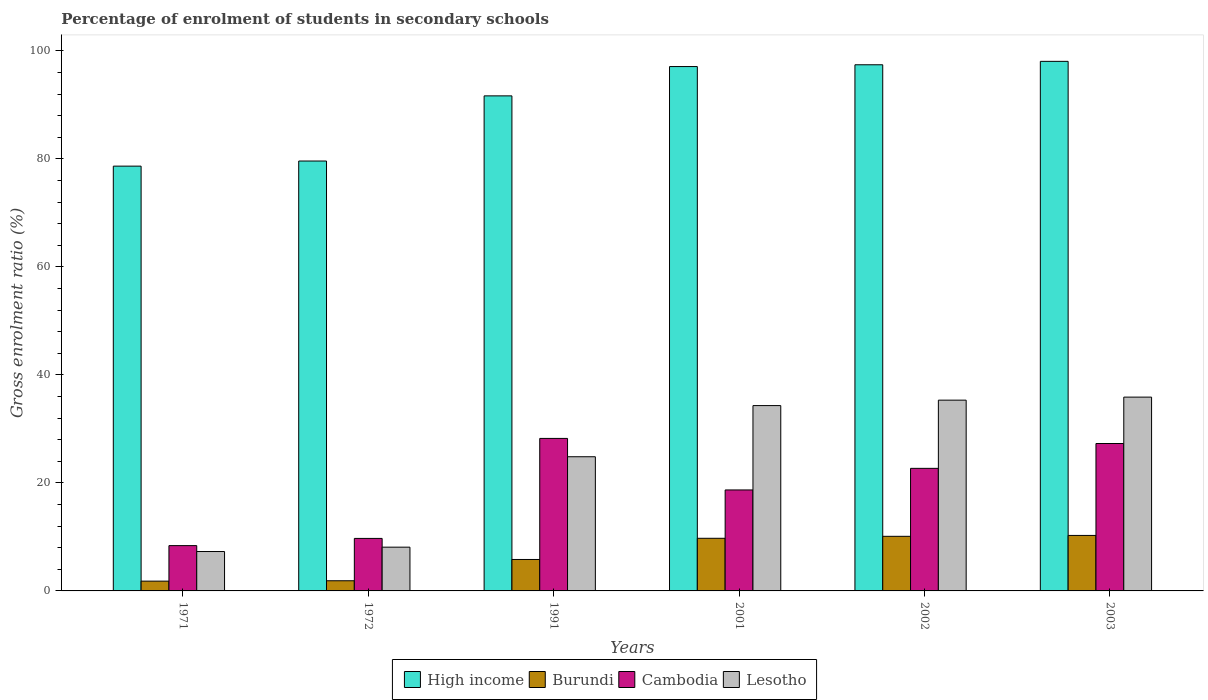Are the number of bars per tick equal to the number of legend labels?
Keep it short and to the point. Yes. How many bars are there on the 6th tick from the left?
Your answer should be very brief. 4. What is the label of the 6th group of bars from the left?
Keep it short and to the point. 2003. What is the percentage of students enrolled in secondary schools in High income in 2003?
Provide a short and direct response. 98.05. Across all years, what is the maximum percentage of students enrolled in secondary schools in High income?
Give a very brief answer. 98.05. Across all years, what is the minimum percentage of students enrolled in secondary schools in Cambodia?
Keep it short and to the point. 8.39. In which year was the percentage of students enrolled in secondary schools in Cambodia minimum?
Provide a succinct answer. 1971. What is the total percentage of students enrolled in secondary schools in Burundi in the graph?
Ensure brevity in your answer.  39.65. What is the difference between the percentage of students enrolled in secondary schools in Cambodia in 1991 and that in 2002?
Your answer should be compact. 5.55. What is the difference between the percentage of students enrolled in secondary schools in Lesotho in 2001 and the percentage of students enrolled in secondary schools in Cambodia in 1971?
Your answer should be compact. 25.93. What is the average percentage of students enrolled in secondary schools in Cambodia per year?
Your answer should be compact. 19.17. In the year 1991, what is the difference between the percentage of students enrolled in secondary schools in Cambodia and percentage of students enrolled in secondary schools in Burundi?
Your answer should be very brief. 22.42. What is the ratio of the percentage of students enrolled in secondary schools in Cambodia in 2002 to that in 2003?
Provide a short and direct response. 0.83. Is the difference between the percentage of students enrolled in secondary schools in Cambodia in 1991 and 2001 greater than the difference between the percentage of students enrolled in secondary schools in Burundi in 1991 and 2001?
Give a very brief answer. Yes. What is the difference between the highest and the second highest percentage of students enrolled in secondary schools in Cambodia?
Give a very brief answer. 0.94. What is the difference between the highest and the lowest percentage of students enrolled in secondary schools in Burundi?
Ensure brevity in your answer.  8.46. In how many years, is the percentage of students enrolled in secondary schools in Burundi greater than the average percentage of students enrolled in secondary schools in Burundi taken over all years?
Provide a short and direct response. 3. Is the sum of the percentage of students enrolled in secondary schools in Cambodia in 1971 and 1991 greater than the maximum percentage of students enrolled in secondary schools in High income across all years?
Offer a very short reply. No. What does the 4th bar from the left in 1971 represents?
Ensure brevity in your answer.  Lesotho. What does the 1st bar from the right in 1971 represents?
Your response must be concise. Lesotho. How many bars are there?
Your answer should be compact. 24. What is the difference between two consecutive major ticks on the Y-axis?
Provide a short and direct response. 20. Are the values on the major ticks of Y-axis written in scientific E-notation?
Your answer should be very brief. No. Where does the legend appear in the graph?
Offer a very short reply. Bottom center. How are the legend labels stacked?
Provide a succinct answer. Horizontal. What is the title of the graph?
Make the answer very short. Percentage of enrolment of students in secondary schools. Does "Japan" appear as one of the legend labels in the graph?
Ensure brevity in your answer.  No. What is the label or title of the Y-axis?
Offer a very short reply. Gross enrolment ratio (%). What is the Gross enrolment ratio (%) of High income in 1971?
Offer a very short reply. 78.65. What is the Gross enrolment ratio (%) of Burundi in 1971?
Offer a terse response. 1.81. What is the Gross enrolment ratio (%) of Cambodia in 1971?
Provide a succinct answer. 8.39. What is the Gross enrolment ratio (%) of Lesotho in 1971?
Provide a succinct answer. 7.29. What is the Gross enrolment ratio (%) in High income in 1972?
Your response must be concise. 79.6. What is the Gross enrolment ratio (%) in Burundi in 1972?
Make the answer very short. 1.88. What is the Gross enrolment ratio (%) in Cambodia in 1972?
Give a very brief answer. 9.72. What is the Gross enrolment ratio (%) of Lesotho in 1972?
Provide a succinct answer. 8.1. What is the Gross enrolment ratio (%) in High income in 1991?
Your answer should be very brief. 91.66. What is the Gross enrolment ratio (%) in Burundi in 1991?
Keep it short and to the point. 5.82. What is the Gross enrolment ratio (%) in Cambodia in 1991?
Offer a very short reply. 28.24. What is the Gross enrolment ratio (%) of Lesotho in 1991?
Your response must be concise. 24.84. What is the Gross enrolment ratio (%) in High income in 2001?
Your answer should be very brief. 97.09. What is the Gross enrolment ratio (%) in Burundi in 2001?
Your response must be concise. 9.75. What is the Gross enrolment ratio (%) of Cambodia in 2001?
Provide a short and direct response. 18.7. What is the Gross enrolment ratio (%) in Lesotho in 2001?
Your answer should be very brief. 34.32. What is the Gross enrolment ratio (%) in High income in 2002?
Make the answer very short. 97.42. What is the Gross enrolment ratio (%) in Burundi in 2002?
Your answer should be compact. 10.11. What is the Gross enrolment ratio (%) in Cambodia in 2002?
Offer a very short reply. 22.69. What is the Gross enrolment ratio (%) in Lesotho in 2002?
Offer a very short reply. 35.32. What is the Gross enrolment ratio (%) in High income in 2003?
Provide a succinct answer. 98.05. What is the Gross enrolment ratio (%) in Burundi in 2003?
Offer a very short reply. 10.27. What is the Gross enrolment ratio (%) in Cambodia in 2003?
Your response must be concise. 27.29. What is the Gross enrolment ratio (%) in Lesotho in 2003?
Provide a short and direct response. 35.88. Across all years, what is the maximum Gross enrolment ratio (%) in High income?
Keep it short and to the point. 98.05. Across all years, what is the maximum Gross enrolment ratio (%) of Burundi?
Your answer should be very brief. 10.27. Across all years, what is the maximum Gross enrolment ratio (%) in Cambodia?
Offer a terse response. 28.24. Across all years, what is the maximum Gross enrolment ratio (%) in Lesotho?
Ensure brevity in your answer.  35.88. Across all years, what is the minimum Gross enrolment ratio (%) of High income?
Ensure brevity in your answer.  78.65. Across all years, what is the minimum Gross enrolment ratio (%) in Burundi?
Provide a succinct answer. 1.81. Across all years, what is the minimum Gross enrolment ratio (%) of Cambodia?
Keep it short and to the point. 8.39. Across all years, what is the minimum Gross enrolment ratio (%) of Lesotho?
Your answer should be very brief. 7.29. What is the total Gross enrolment ratio (%) of High income in the graph?
Ensure brevity in your answer.  542.47. What is the total Gross enrolment ratio (%) of Burundi in the graph?
Provide a succinct answer. 39.65. What is the total Gross enrolment ratio (%) in Cambodia in the graph?
Give a very brief answer. 115.03. What is the total Gross enrolment ratio (%) in Lesotho in the graph?
Your response must be concise. 145.76. What is the difference between the Gross enrolment ratio (%) of High income in 1971 and that in 1972?
Your response must be concise. -0.95. What is the difference between the Gross enrolment ratio (%) of Burundi in 1971 and that in 1972?
Provide a succinct answer. -0.07. What is the difference between the Gross enrolment ratio (%) in Cambodia in 1971 and that in 1972?
Give a very brief answer. -1.33. What is the difference between the Gross enrolment ratio (%) in Lesotho in 1971 and that in 1972?
Ensure brevity in your answer.  -0.81. What is the difference between the Gross enrolment ratio (%) of High income in 1971 and that in 1991?
Provide a succinct answer. -13.01. What is the difference between the Gross enrolment ratio (%) in Burundi in 1971 and that in 1991?
Offer a terse response. -4.01. What is the difference between the Gross enrolment ratio (%) in Cambodia in 1971 and that in 1991?
Provide a succinct answer. -19.85. What is the difference between the Gross enrolment ratio (%) in Lesotho in 1971 and that in 1991?
Provide a succinct answer. -17.55. What is the difference between the Gross enrolment ratio (%) of High income in 1971 and that in 2001?
Ensure brevity in your answer.  -18.44. What is the difference between the Gross enrolment ratio (%) of Burundi in 1971 and that in 2001?
Your answer should be very brief. -7.93. What is the difference between the Gross enrolment ratio (%) in Cambodia in 1971 and that in 2001?
Your answer should be compact. -10.31. What is the difference between the Gross enrolment ratio (%) of Lesotho in 1971 and that in 2001?
Provide a succinct answer. -27.02. What is the difference between the Gross enrolment ratio (%) of High income in 1971 and that in 2002?
Offer a very short reply. -18.77. What is the difference between the Gross enrolment ratio (%) of Burundi in 1971 and that in 2002?
Your answer should be very brief. -8.3. What is the difference between the Gross enrolment ratio (%) in Cambodia in 1971 and that in 2002?
Your answer should be very brief. -14.31. What is the difference between the Gross enrolment ratio (%) in Lesotho in 1971 and that in 2002?
Give a very brief answer. -28.03. What is the difference between the Gross enrolment ratio (%) in High income in 1971 and that in 2003?
Keep it short and to the point. -19.4. What is the difference between the Gross enrolment ratio (%) of Burundi in 1971 and that in 2003?
Ensure brevity in your answer.  -8.46. What is the difference between the Gross enrolment ratio (%) of Cambodia in 1971 and that in 2003?
Offer a terse response. -18.91. What is the difference between the Gross enrolment ratio (%) in Lesotho in 1971 and that in 2003?
Offer a very short reply. -28.59. What is the difference between the Gross enrolment ratio (%) in High income in 1972 and that in 1991?
Offer a very short reply. -12.06. What is the difference between the Gross enrolment ratio (%) in Burundi in 1972 and that in 1991?
Provide a short and direct response. -3.94. What is the difference between the Gross enrolment ratio (%) of Cambodia in 1972 and that in 1991?
Provide a succinct answer. -18.52. What is the difference between the Gross enrolment ratio (%) of Lesotho in 1972 and that in 1991?
Your response must be concise. -16.74. What is the difference between the Gross enrolment ratio (%) in High income in 1972 and that in 2001?
Make the answer very short. -17.49. What is the difference between the Gross enrolment ratio (%) in Burundi in 1972 and that in 2001?
Offer a very short reply. -7.86. What is the difference between the Gross enrolment ratio (%) of Cambodia in 1972 and that in 2001?
Provide a short and direct response. -8.98. What is the difference between the Gross enrolment ratio (%) of Lesotho in 1972 and that in 2001?
Offer a terse response. -26.21. What is the difference between the Gross enrolment ratio (%) of High income in 1972 and that in 2002?
Make the answer very short. -17.82. What is the difference between the Gross enrolment ratio (%) of Burundi in 1972 and that in 2002?
Make the answer very short. -8.23. What is the difference between the Gross enrolment ratio (%) of Cambodia in 1972 and that in 2002?
Your answer should be compact. -12.97. What is the difference between the Gross enrolment ratio (%) in Lesotho in 1972 and that in 2002?
Keep it short and to the point. -27.22. What is the difference between the Gross enrolment ratio (%) in High income in 1972 and that in 2003?
Make the answer very short. -18.45. What is the difference between the Gross enrolment ratio (%) in Burundi in 1972 and that in 2003?
Your answer should be compact. -8.39. What is the difference between the Gross enrolment ratio (%) in Cambodia in 1972 and that in 2003?
Your answer should be compact. -17.57. What is the difference between the Gross enrolment ratio (%) of Lesotho in 1972 and that in 2003?
Your response must be concise. -27.78. What is the difference between the Gross enrolment ratio (%) in High income in 1991 and that in 2001?
Give a very brief answer. -5.43. What is the difference between the Gross enrolment ratio (%) in Burundi in 1991 and that in 2001?
Your answer should be very brief. -3.92. What is the difference between the Gross enrolment ratio (%) of Cambodia in 1991 and that in 2001?
Keep it short and to the point. 9.54. What is the difference between the Gross enrolment ratio (%) in Lesotho in 1991 and that in 2001?
Provide a succinct answer. -9.47. What is the difference between the Gross enrolment ratio (%) in High income in 1991 and that in 2002?
Provide a short and direct response. -5.76. What is the difference between the Gross enrolment ratio (%) in Burundi in 1991 and that in 2002?
Provide a succinct answer. -4.29. What is the difference between the Gross enrolment ratio (%) of Cambodia in 1991 and that in 2002?
Offer a terse response. 5.55. What is the difference between the Gross enrolment ratio (%) of Lesotho in 1991 and that in 2002?
Provide a succinct answer. -10.48. What is the difference between the Gross enrolment ratio (%) of High income in 1991 and that in 2003?
Your answer should be compact. -6.39. What is the difference between the Gross enrolment ratio (%) in Burundi in 1991 and that in 2003?
Keep it short and to the point. -4.45. What is the difference between the Gross enrolment ratio (%) of Cambodia in 1991 and that in 2003?
Offer a very short reply. 0.94. What is the difference between the Gross enrolment ratio (%) in Lesotho in 1991 and that in 2003?
Provide a succinct answer. -11.04. What is the difference between the Gross enrolment ratio (%) in High income in 2001 and that in 2002?
Keep it short and to the point. -0.33. What is the difference between the Gross enrolment ratio (%) of Burundi in 2001 and that in 2002?
Provide a succinct answer. -0.36. What is the difference between the Gross enrolment ratio (%) in Cambodia in 2001 and that in 2002?
Your answer should be compact. -4. What is the difference between the Gross enrolment ratio (%) in Lesotho in 2001 and that in 2002?
Make the answer very short. -1.01. What is the difference between the Gross enrolment ratio (%) of High income in 2001 and that in 2003?
Your answer should be very brief. -0.96. What is the difference between the Gross enrolment ratio (%) in Burundi in 2001 and that in 2003?
Provide a short and direct response. -0.53. What is the difference between the Gross enrolment ratio (%) of Cambodia in 2001 and that in 2003?
Your answer should be very brief. -8.6. What is the difference between the Gross enrolment ratio (%) of Lesotho in 2001 and that in 2003?
Offer a terse response. -1.57. What is the difference between the Gross enrolment ratio (%) in High income in 2002 and that in 2003?
Keep it short and to the point. -0.63. What is the difference between the Gross enrolment ratio (%) of Burundi in 2002 and that in 2003?
Ensure brevity in your answer.  -0.16. What is the difference between the Gross enrolment ratio (%) in Cambodia in 2002 and that in 2003?
Keep it short and to the point. -4.6. What is the difference between the Gross enrolment ratio (%) in Lesotho in 2002 and that in 2003?
Provide a succinct answer. -0.56. What is the difference between the Gross enrolment ratio (%) in High income in 1971 and the Gross enrolment ratio (%) in Burundi in 1972?
Your answer should be compact. 76.77. What is the difference between the Gross enrolment ratio (%) of High income in 1971 and the Gross enrolment ratio (%) of Cambodia in 1972?
Provide a succinct answer. 68.93. What is the difference between the Gross enrolment ratio (%) of High income in 1971 and the Gross enrolment ratio (%) of Lesotho in 1972?
Your response must be concise. 70.55. What is the difference between the Gross enrolment ratio (%) in Burundi in 1971 and the Gross enrolment ratio (%) in Cambodia in 1972?
Your response must be concise. -7.91. What is the difference between the Gross enrolment ratio (%) in Burundi in 1971 and the Gross enrolment ratio (%) in Lesotho in 1972?
Keep it short and to the point. -6.29. What is the difference between the Gross enrolment ratio (%) in Cambodia in 1971 and the Gross enrolment ratio (%) in Lesotho in 1972?
Ensure brevity in your answer.  0.29. What is the difference between the Gross enrolment ratio (%) of High income in 1971 and the Gross enrolment ratio (%) of Burundi in 1991?
Ensure brevity in your answer.  72.83. What is the difference between the Gross enrolment ratio (%) in High income in 1971 and the Gross enrolment ratio (%) in Cambodia in 1991?
Make the answer very short. 50.41. What is the difference between the Gross enrolment ratio (%) of High income in 1971 and the Gross enrolment ratio (%) of Lesotho in 1991?
Make the answer very short. 53.81. What is the difference between the Gross enrolment ratio (%) of Burundi in 1971 and the Gross enrolment ratio (%) of Cambodia in 1991?
Ensure brevity in your answer.  -26.43. What is the difference between the Gross enrolment ratio (%) in Burundi in 1971 and the Gross enrolment ratio (%) in Lesotho in 1991?
Ensure brevity in your answer.  -23.03. What is the difference between the Gross enrolment ratio (%) of Cambodia in 1971 and the Gross enrolment ratio (%) of Lesotho in 1991?
Your answer should be very brief. -16.46. What is the difference between the Gross enrolment ratio (%) of High income in 1971 and the Gross enrolment ratio (%) of Burundi in 2001?
Your answer should be very brief. 68.91. What is the difference between the Gross enrolment ratio (%) in High income in 1971 and the Gross enrolment ratio (%) in Cambodia in 2001?
Your answer should be compact. 59.95. What is the difference between the Gross enrolment ratio (%) of High income in 1971 and the Gross enrolment ratio (%) of Lesotho in 2001?
Make the answer very short. 44.34. What is the difference between the Gross enrolment ratio (%) of Burundi in 1971 and the Gross enrolment ratio (%) of Cambodia in 2001?
Your response must be concise. -16.89. What is the difference between the Gross enrolment ratio (%) of Burundi in 1971 and the Gross enrolment ratio (%) of Lesotho in 2001?
Your response must be concise. -32.5. What is the difference between the Gross enrolment ratio (%) in Cambodia in 1971 and the Gross enrolment ratio (%) in Lesotho in 2001?
Your response must be concise. -25.93. What is the difference between the Gross enrolment ratio (%) of High income in 1971 and the Gross enrolment ratio (%) of Burundi in 2002?
Your answer should be compact. 68.54. What is the difference between the Gross enrolment ratio (%) of High income in 1971 and the Gross enrolment ratio (%) of Cambodia in 2002?
Your response must be concise. 55.96. What is the difference between the Gross enrolment ratio (%) of High income in 1971 and the Gross enrolment ratio (%) of Lesotho in 2002?
Provide a short and direct response. 43.33. What is the difference between the Gross enrolment ratio (%) of Burundi in 1971 and the Gross enrolment ratio (%) of Cambodia in 2002?
Your response must be concise. -20.88. What is the difference between the Gross enrolment ratio (%) of Burundi in 1971 and the Gross enrolment ratio (%) of Lesotho in 2002?
Offer a very short reply. -33.51. What is the difference between the Gross enrolment ratio (%) in Cambodia in 1971 and the Gross enrolment ratio (%) in Lesotho in 2002?
Offer a very short reply. -26.93. What is the difference between the Gross enrolment ratio (%) of High income in 1971 and the Gross enrolment ratio (%) of Burundi in 2003?
Give a very brief answer. 68.38. What is the difference between the Gross enrolment ratio (%) in High income in 1971 and the Gross enrolment ratio (%) in Cambodia in 2003?
Provide a succinct answer. 51.36. What is the difference between the Gross enrolment ratio (%) of High income in 1971 and the Gross enrolment ratio (%) of Lesotho in 2003?
Your answer should be very brief. 42.77. What is the difference between the Gross enrolment ratio (%) of Burundi in 1971 and the Gross enrolment ratio (%) of Cambodia in 2003?
Make the answer very short. -25.48. What is the difference between the Gross enrolment ratio (%) of Burundi in 1971 and the Gross enrolment ratio (%) of Lesotho in 2003?
Your answer should be compact. -34.07. What is the difference between the Gross enrolment ratio (%) in Cambodia in 1971 and the Gross enrolment ratio (%) in Lesotho in 2003?
Make the answer very short. -27.5. What is the difference between the Gross enrolment ratio (%) of High income in 1972 and the Gross enrolment ratio (%) of Burundi in 1991?
Your response must be concise. 73.78. What is the difference between the Gross enrolment ratio (%) in High income in 1972 and the Gross enrolment ratio (%) in Cambodia in 1991?
Give a very brief answer. 51.36. What is the difference between the Gross enrolment ratio (%) of High income in 1972 and the Gross enrolment ratio (%) of Lesotho in 1991?
Make the answer very short. 54.76. What is the difference between the Gross enrolment ratio (%) in Burundi in 1972 and the Gross enrolment ratio (%) in Cambodia in 1991?
Provide a succinct answer. -26.36. What is the difference between the Gross enrolment ratio (%) of Burundi in 1972 and the Gross enrolment ratio (%) of Lesotho in 1991?
Your answer should be compact. -22.96. What is the difference between the Gross enrolment ratio (%) of Cambodia in 1972 and the Gross enrolment ratio (%) of Lesotho in 1991?
Your answer should be very brief. -15.12. What is the difference between the Gross enrolment ratio (%) of High income in 1972 and the Gross enrolment ratio (%) of Burundi in 2001?
Your response must be concise. 69.85. What is the difference between the Gross enrolment ratio (%) in High income in 1972 and the Gross enrolment ratio (%) in Cambodia in 2001?
Keep it short and to the point. 60.9. What is the difference between the Gross enrolment ratio (%) of High income in 1972 and the Gross enrolment ratio (%) of Lesotho in 2001?
Offer a terse response. 45.28. What is the difference between the Gross enrolment ratio (%) in Burundi in 1972 and the Gross enrolment ratio (%) in Cambodia in 2001?
Provide a succinct answer. -16.82. What is the difference between the Gross enrolment ratio (%) in Burundi in 1972 and the Gross enrolment ratio (%) in Lesotho in 2001?
Make the answer very short. -32.43. What is the difference between the Gross enrolment ratio (%) of Cambodia in 1972 and the Gross enrolment ratio (%) of Lesotho in 2001?
Offer a very short reply. -24.59. What is the difference between the Gross enrolment ratio (%) of High income in 1972 and the Gross enrolment ratio (%) of Burundi in 2002?
Offer a terse response. 69.49. What is the difference between the Gross enrolment ratio (%) of High income in 1972 and the Gross enrolment ratio (%) of Cambodia in 2002?
Your response must be concise. 56.9. What is the difference between the Gross enrolment ratio (%) in High income in 1972 and the Gross enrolment ratio (%) in Lesotho in 2002?
Keep it short and to the point. 44.28. What is the difference between the Gross enrolment ratio (%) in Burundi in 1972 and the Gross enrolment ratio (%) in Cambodia in 2002?
Your answer should be compact. -20.81. What is the difference between the Gross enrolment ratio (%) in Burundi in 1972 and the Gross enrolment ratio (%) in Lesotho in 2002?
Offer a terse response. -33.44. What is the difference between the Gross enrolment ratio (%) in Cambodia in 1972 and the Gross enrolment ratio (%) in Lesotho in 2002?
Offer a terse response. -25.6. What is the difference between the Gross enrolment ratio (%) of High income in 1972 and the Gross enrolment ratio (%) of Burundi in 2003?
Keep it short and to the point. 69.32. What is the difference between the Gross enrolment ratio (%) of High income in 1972 and the Gross enrolment ratio (%) of Cambodia in 2003?
Offer a terse response. 52.3. What is the difference between the Gross enrolment ratio (%) in High income in 1972 and the Gross enrolment ratio (%) in Lesotho in 2003?
Offer a terse response. 43.71. What is the difference between the Gross enrolment ratio (%) of Burundi in 1972 and the Gross enrolment ratio (%) of Cambodia in 2003?
Your response must be concise. -25.41. What is the difference between the Gross enrolment ratio (%) of Burundi in 1972 and the Gross enrolment ratio (%) of Lesotho in 2003?
Keep it short and to the point. -34. What is the difference between the Gross enrolment ratio (%) of Cambodia in 1972 and the Gross enrolment ratio (%) of Lesotho in 2003?
Offer a terse response. -26.16. What is the difference between the Gross enrolment ratio (%) in High income in 1991 and the Gross enrolment ratio (%) in Burundi in 2001?
Ensure brevity in your answer.  81.92. What is the difference between the Gross enrolment ratio (%) in High income in 1991 and the Gross enrolment ratio (%) in Cambodia in 2001?
Offer a very short reply. 72.97. What is the difference between the Gross enrolment ratio (%) in High income in 1991 and the Gross enrolment ratio (%) in Lesotho in 2001?
Your answer should be compact. 57.35. What is the difference between the Gross enrolment ratio (%) of Burundi in 1991 and the Gross enrolment ratio (%) of Cambodia in 2001?
Keep it short and to the point. -12.88. What is the difference between the Gross enrolment ratio (%) of Burundi in 1991 and the Gross enrolment ratio (%) of Lesotho in 2001?
Your response must be concise. -28.49. What is the difference between the Gross enrolment ratio (%) in Cambodia in 1991 and the Gross enrolment ratio (%) in Lesotho in 2001?
Make the answer very short. -6.08. What is the difference between the Gross enrolment ratio (%) in High income in 1991 and the Gross enrolment ratio (%) in Burundi in 2002?
Ensure brevity in your answer.  81.55. What is the difference between the Gross enrolment ratio (%) of High income in 1991 and the Gross enrolment ratio (%) of Cambodia in 2002?
Your response must be concise. 68.97. What is the difference between the Gross enrolment ratio (%) in High income in 1991 and the Gross enrolment ratio (%) in Lesotho in 2002?
Your answer should be compact. 56.34. What is the difference between the Gross enrolment ratio (%) in Burundi in 1991 and the Gross enrolment ratio (%) in Cambodia in 2002?
Offer a very short reply. -16.87. What is the difference between the Gross enrolment ratio (%) of Burundi in 1991 and the Gross enrolment ratio (%) of Lesotho in 2002?
Keep it short and to the point. -29.5. What is the difference between the Gross enrolment ratio (%) of Cambodia in 1991 and the Gross enrolment ratio (%) of Lesotho in 2002?
Provide a succinct answer. -7.08. What is the difference between the Gross enrolment ratio (%) of High income in 1991 and the Gross enrolment ratio (%) of Burundi in 2003?
Ensure brevity in your answer.  81.39. What is the difference between the Gross enrolment ratio (%) in High income in 1991 and the Gross enrolment ratio (%) in Cambodia in 2003?
Your answer should be very brief. 64.37. What is the difference between the Gross enrolment ratio (%) in High income in 1991 and the Gross enrolment ratio (%) in Lesotho in 2003?
Make the answer very short. 55.78. What is the difference between the Gross enrolment ratio (%) in Burundi in 1991 and the Gross enrolment ratio (%) in Cambodia in 2003?
Your response must be concise. -21.47. What is the difference between the Gross enrolment ratio (%) of Burundi in 1991 and the Gross enrolment ratio (%) of Lesotho in 2003?
Give a very brief answer. -30.06. What is the difference between the Gross enrolment ratio (%) of Cambodia in 1991 and the Gross enrolment ratio (%) of Lesotho in 2003?
Ensure brevity in your answer.  -7.64. What is the difference between the Gross enrolment ratio (%) of High income in 2001 and the Gross enrolment ratio (%) of Burundi in 2002?
Make the answer very short. 86.98. What is the difference between the Gross enrolment ratio (%) of High income in 2001 and the Gross enrolment ratio (%) of Cambodia in 2002?
Offer a very short reply. 74.4. What is the difference between the Gross enrolment ratio (%) of High income in 2001 and the Gross enrolment ratio (%) of Lesotho in 2002?
Provide a short and direct response. 61.77. What is the difference between the Gross enrolment ratio (%) in Burundi in 2001 and the Gross enrolment ratio (%) in Cambodia in 2002?
Offer a very short reply. -12.95. What is the difference between the Gross enrolment ratio (%) of Burundi in 2001 and the Gross enrolment ratio (%) of Lesotho in 2002?
Offer a terse response. -25.58. What is the difference between the Gross enrolment ratio (%) of Cambodia in 2001 and the Gross enrolment ratio (%) of Lesotho in 2002?
Ensure brevity in your answer.  -16.62. What is the difference between the Gross enrolment ratio (%) of High income in 2001 and the Gross enrolment ratio (%) of Burundi in 2003?
Provide a short and direct response. 86.82. What is the difference between the Gross enrolment ratio (%) of High income in 2001 and the Gross enrolment ratio (%) of Cambodia in 2003?
Your answer should be compact. 69.8. What is the difference between the Gross enrolment ratio (%) in High income in 2001 and the Gross enrolment ratio (%) in Lesotho in 2003?
Offer a terse response. 61.21. What is the difference between the Gross enrolment ratio (%) of Burundi in 2001 and the Gross enrolment ratio (%) of Cambodia in 2003?
Offer a terse response. -17.55. What is the difference between the Gross enrolment ratio (%) in Burundi in 2001 and the Gross enrolment ratio (%) in Lesotho in 2003?
Your answer should be very brief. -26.14. What is the difference between the Gross enrolment ratio (%) of Cambodia in 2001 and the Gross enrolment ratio (%) of Lesotho in 2003?
Ensure brevity in your answer.  -17.19. What is the difference between the Gross enrolment ratio (%) in High income in 2002 and the Gross enrolment ratio (%) in Burundi in 2003?
Ensure brevity in your answer.  87.14. What is the difference between the Gross enrolment ratio (%) in High income in 2002 and the Gross enrolment ratio (%) in Cambodia in 2003?
Make the answer very short. 70.12. What is the difference between the Gross enrolment ratio (%) in High income in 2002 and the Gross enrolment ratio (%) in Lesotho in 2003?
Ensure brevity in your answer.  61.53. What is the difference between the Gross enrolment ratio (%) of Burundi in 2002 and the Gross enrolment ratio (%) of Cambodia in 2003?
Keep it short and to the point. -17.18. What is the difference between the Gross enrolment ratio (%) of Burundi in 2002 and the Gross enrolment ratio (%) of Lesotho in 2003?
Offer a terse response. -25.77. What is the difference between the Gross enrolment ratio (%) of Cambodia in 2002 and the Gross enrolment ratio (%) of Lesotho in 2003?
Give a very brief answer. -13.19. What is the average Gross enrolment ratio (%) in High income per year?
Ensure brevity in your answer.  90.41. What is the average Gross enrolment ratio (%) in Burundi per year?
Make the answer very short. 6.61. What is the average Gross enrolment ratio (%) in Cambodia per year?
Make the answer very short. 19.17. What is the average Gross enrolment ratio (%) in Lesotho per year?
Your answer should be compact. 24.29. In the year 1971, what is the difference between the Gross enrolment ratio (%) of High income and Gross enrolment ratio (%) of Burundi?
Ensure brevity in your answer.  76.84. In the year 1971, what is the difference between the Gross enrolment ratio (%) in High income and Gross enrolment ratio (%) in Cambodia?
Your answer should be very brief. 70.26. In the year 1971, what is the difference between the Gross enrolment ratio (%) in High income and Gross enrolment ratio (%) in Lesotho?
Make the answer very short. 71.36. In the year 1971, what is the difference between the Gross enrolment ratio (%) in Burundi and Gross enrolment ratio (%) in Cambodia?
Give a very brief answer. -6.58. In the year 1971, what is the difference between the Gross enrolment ratio (%) in Burundi and Gross enrolment ratio (%) in Lesotho?
Offer a very short reply. -5.48. In the year 1971, what is the difference between the Gross enrolment ratio (%) of Cambodia and Gross enrolment ratio (%) of Lesotho?
Make the answer very short. 1.09. In the year 1972, what is the difference between the Gross enrolment ratio (%) of High income and Gross enrolment ratio (%) of Burundi?
Offer a very short reply. 77.72. In the year 1972, what is the difference between the Gross enrolment ratio (%) of High income and Gross enrolment ratio (%) of Cambodia?
Provide a short and direct response. 69.88. In the year 1972, what is the difference between the Gross enrolment ratio (%) in High income and Gross enrolment ratio (%) in Lesotho?
Your answer should be very brief. 71.5. In the year 1972, what is the difference between the Gross enrolment ratio (%) in Burundi and Gross enrolment ratio (%) in Cambodia?
Offer a terse response. -7.84. In the year 1972, what is the difference between the Gross enrolment ratio (%) in Burundi and Gross enrolment ratio (%) in Lesotho?
Ensure brevity in your answer.  -6.22. In the year 1972, what is the difference between the Gross enrolment ratio (%) of Cambodia and Gross enrolment ratio (%) of Lesotho?
Offer a terse response. 1.62. In the year 1991, what is the difference between the Gross enrolment ratio (%) in High income and Gross enrolment ratio (%) in Burundi?
Your answer should be very brief. 85.84. In the year 1991, what is the difference between the Gross enrolment ratio (%) in High income and Gross enrolment ratio (%) in Cambodia?
Your response must be concise. 63.42. In the year 1991, what is the difference between the Gross enrolment ratio (%) in High income and Gross enrolment ratio (%) in Lesotho?
Make the answer very short. 66.82. In the year 1991, what is the difference between the Gross enrolment ratio (%) of Burundi and Gross enrolment ratio (%) of Cambodia?
Offer a terse response. -22.42. In the year 1991, what is the difference between the Gross enrolment ratio (%) in Burundi and Gross enrolment ratio (%) in Lesotho?
Your answer should be very brief. -19.02. In the year 1991, what is the difference between the Gross enrolment ratio (%) in Cambodia and Gross enrolment ratio (%) in Lesotho?
Provide a short and direct response. 3.4. In the year 2001, what is the difference between the Gross enrolment ratio (%) in High income and Gross enrolment ratio (%) in Burundi?
Provide a succinct answer. 87.34. In the year 2001, what is the difference between the Gross enrolment ratio (%) in High income and Gross enrolment ratio (%) in Cambodia?
Make the answer very short. 78.39. In the year 2001, what is the difference between the Gross enrolment ratio (%) in High income and Gross enrolment ratio (%) in Lesotho?
Provide a short and direct response. 62.77. In the year 2001, what is the difference between the Gross enrolment ratio (%) in Burundi and Gross enrolment ratio (%) in Cambodia?
Your response must be concise. -8.95. In the year 2001, what is the difference between the Gross enrolment ratio (%) of Burundi and Gross enrolment ratio (%) of Lesotho?
Provide a succinct answer. -24.57. In the year 2001, what is the difference between the Gross enrolment ratio (%) in Cambodia and Gross enrolment ratio (%) in Lesotho?
Make the answer very short. -15.62. In the year 2002, what is the difference between the Gross enrolment ratio (%) in High income and Gross enrolment ratio (%) in Burundi?
Keep it short and to the point. 87.31. In the year 2002, what is the difference between the Gross enrolment ratio (%) in High income and Gross enrolment ratio (%) in Cambodia?
Provide a succinct answer. 74.72. In the year 2002, what is the difference between the Gross enrolment ratio (%) in High income and Gross enrolment ratio (%) in Lesotho?
Provide a short and direct response. 62.1. In the year 2002, what is the difference between the Gross enrolment ratio (%) in Burundi and Gross enrolment ratio (%) in Cambodia?
Offer a very short reply. -12.58. In the year 2002, what is the difference between the Gross enrolment ratio (%) of Burundi and Gross enrolment ratio (%) of Lesotho?
Your answer should be very brief. -25.21. In the year 2002, what is the difference between the Gross enrolment ratio (%) of Cambodia and Gross enrolment ratio (%) of Lesotho?
Provide a short and direct response. -12.63. In the year 2003, what is the difference between the Gross enrolment ratio (%) in High income and Gross enrolment ratio (%) in Burundi?
Provide a short and direct response. 87.78. In the year 2003, what is the difference between the Gross enrolment ratio (%) of High income and Gross enrolment ratio (%) of Cambodia?
Offer a very short reply. 70.76. In the year 2003, what is the difference between the Gross enrolment ratio (%) of High income and Gross enrolment ratio (%) of Lesotho?
Keep it short and to the point. 62.17. In the year 2003, what is the difference between the Gross enrolment ratio (%) of Burundi and Gross enrolment ratio (%) of Cambodia?
Make the answer very short. -17.02. In the year 2003, what is the difference between the Gross enrolment ratio (%) of Burundi and Gross enrolment ratio (%) of Lesotho?
Offer a terse response. -25.61. In the year 2003, what is the difference between the Gross enrolment ratio (%) of Cambodia and Gross enrolment ratio (%) of Lesotho?
Provide a succinct answer. -8.59. What is the ratio of the Gross enrolment ratio (%) in High income in 1971 to that in 1972?
Make the answer very short. 0.99. What is the ratio of the Gross enrolment ratio (%) in Burundi in 1971 to that in 1972?
Ensure brevity in your answer.  0.96. What is the ratio of the Gross enrolment ratio (%) in Cambodia in 1971 to that in 1972?
Offer a terse response. 0.86. What is the ratio of the Gross enrolment ratio (%) of Lesotho in 1971 to that in 1972?
Your answer should be very brief. 0.9. What is the ratio of the Gross enrolment ratio (%) in High income in 1971 to that in 1991?
Keep it short and to the point. 0.86. What is the ratio of the Gross enrolment ratio (%) of Burundi in 1971 to that in 1991?
Ensure brevity in your answer.  0.31. What is the ratio of the Gross enrolment ratio (%) in Cambodia in 1971 to that in 1991?
Offer a very short reply. 0.3. What is the ratio of the Gross enrolment ratio (%) of Lesotho in 1971 to that in 1991?
Give a very brief answer. 0.29. What is the ratio of the Gross enrolment ratio (%) in High income in 1971 to that in 2001?
Provide a succinct answer. 0.81. What is the ratio of the Gross enrolment ratio (%) of Burundi in 1971 to that in 2001?
Your answer should be compact. 0.19. What is the ratio of the Gross enrolment ratio (%) in Cambodia in 1971 to that in 2001?
Offer a terse response. 0.45. What is the ratio of the Gross enrolment ratio (%) in Lesotho in 1971 to that in 2001?
Make the answer very short. 0.21. What is the ratio of the Gross enrolment ratio (%) of High income in 1971 to that in 2002?
Make the answer very short. 0.81. What is the ratio of the Gross enrolment ratio (%) in Burundi in 1971 to that in 2002?
Make the answer very short. 0.18. What is the ratio of the Gross enrolment ratio (%) in Cambodia in 1971 to that in 2002?
Your answer should be compact. 0.37. What is the ratio of the Gross enrolment ratio (%) of Lesotho in 1971 to that in 2002?
Your answer should be compact. 0.21. What is the ratio of the Gross enrolment ratio (%) of High income in 1971 to that in 2003?
Your answer should be very brief. 0.8. What is the ratio of the Gross enrolment ratio (%) in Burundi in 1971 to that in 2003?
Provide a short and direct response. 0.18. What is the ratio of the Gross enrolment ratio (%) in Cambodia in 1971 to that in 2003?
Offer a terse response. 0.31. What is the ratio of the Gross enrolment ratio (%) in Lesotho in 1971 to that in 2003?
Make the answer very short. 0.2. What is the ratio of the Gross enrolment ratio (%) of High income in 1972 to that in 1991?
Keep it short and to the point. 0.87. What is the ratio of the Gross enrolment ratio (%) of Burundi in 1972 to that in 1991?
Your response must be concise. 0.32. What is the ratio of the Gross enrolment ratio (%) in Cambodia in 1972 to that in 1991?
Offer a terse response. 0.34. What is the ratio of the Gross enrolment ratio (%) of Lesotho in 1972 to that in 1991?
Provide a short and direct response. 0.33. What is the ratio of the Gross enrolment ratio (%) of High income in 1972 to that in 2001?
Offer a very short reply. 0.82. What is the ratio of the Gross enrolment ratio (%) of Burundi in 1972 to that in 2001?
Offer a very short reply. 0.19. What is the ratio of the Gross enrolment ratio (%) in Cambodia in 1972 to that in 2001?
Ensure brevity in your answer.  0.52. What is the ratio of the Gross enrolment ratio (%) in Lesotho in 1972 to that in 2001?
Provide a short and direct response. 0.24. What is the ratio of the Gross enrolment ratio (%) in High income in 1972 to that in 2002?
Give a very brief answer. 0.82. What is the ratio of the Gross enrolment ratio (%) of Burundi in 1972 to that in 2002?
Ensure brevity in your answer.  0.19. What is the ratio of the Gross enrolment ratio (%) of Cambodia in 1972 to that in 2002?
Provide a succinct answer. 0.43. What is the ratio of the Gross enrolment ratio (%) in Lesotho in 1972 to that in 2002?
Your response must be concise. 0.23. What is the ratio of the Gross enrolment ratio (%) of High income in 1972 to that in 2003?
Your response must be concise. 0.81. What is the ratio of the Gross enrolment ratio (%) in Burundi in 1972 to that in 2003?
Your response must be concise. 0.18. What is the ratio of the Gross enrolment ratio (%) in Cambodia in 1972 to that in 2003?
Offer a very short reply. 0.36. What is the ratio of the Gross enrolment ratio (%) of Lesotho in 1972 to that in 2003?
Give a very brief answer. 0.23. What is the ratio of the Gross enrolment ratio (%) in High income in 1991 to that in 2001?
Make the answer very short. 0.94. What is the ratio of the Gross enrolment ratio (%) in Burundi in 1991 to that in 2001?
Offer a terse response. 0.6. What is the ratio of the Gross enrolment ratio (%) of Cambodia in 1991 to that in 2001?
Your answer should be compact. 1.51. What is the ratio of the Gross enrolment ratio (%) in Lesotho in 1991 to that in 2001?
Offer a very short reply. 0.72. What is the ratio of the Gross enrolment ratio (%) of High income in 1991 to that in 2002?
Make the answer very short. 0.94. What is the ratio of the Gross enrolment ratio (%) in Burundi in 1991 to that in 2002?
Keep it short and to the point. 0.58. What is the ratio of the Gross enrolment ratio (%) in Cambodia in 1991 to that in 2002?
Ensure brevity in your answer.  1.24. What is the ratio of the Gross enrolment ratio (%) of Lesotho in 1991 to that in 2002?
Your answer should be compact. 0.7. What is the ratio of the Gross enrolment ratio (%) in High income in 1991 to that in 2003?
Keep it short and to the point. 0.93. What is the ratio of the Gross enrolment ratio (%) of Burundi in 1991 to that in 2003?
Offer a terse response. 0.57. What is the ratio of the Gross enrolment ratio (%) of Cambodia in 1991 to that in 2003?
Make the answer very short. 1.03. What is the ratio of the Gross enrolment ratio (%) of Lesotho in 1991 to that in 2003?
Offer a terse response. 0.69. What is the ratio of the Gross enrolment ratio (%) in High income in 2001 to that in 2002?
Offer a terse response. 1. What is the ratio of the Gross enrolment ratio (%) of Burundi in 2001 to that in 2002?
Your answer should be compact. 0.96. What is the ratio of the Gross enrolment ratio (%) of Cambodia in 2001 to that in 2002?
Offer a terse response. 0.82. What is the ratio of the Gross enrolment ratio (%) in Lesotho in 2001 to that in 2002?
Give a very brief answer. 0.97. What is the ratio of the Gross enrolment ratio (%) in High income in 2001 to that in 2003?
Your response must be concise. 0.99. What is the ratio of the Gross enrolment ratio (%) of Burundi in 2001 to that in 2003?
Your answer should be compact. 0.95. What is the ratio of the Gross enrolment ratio (%) in Cambodia in 2001 to that in 2003?
Your response must be concise. 0.69. What is the ratio of the Gross enrolment ratio (%) in Lesotho in 2001 to that in 2003?
Offer a terse response. 0.96. What is the ratio of the Gross enrolment ratio (%) in Cambodia in 2002 to that in 2003?
Offer a very short reply. 0.83. What is the ratio of the Gross enrolment ratio (%) of Lesotho in 2002 to that in 2003?
Offer a very short reply. 0.98. What is the difference between the highest and the second highest Gross enrolment ratio (%) of High income?
Offer a very short reply. 0.63. What is the difference between the highest and the second highest Gross enrolment ratio (%) in Burundi?
Provide a succinct answer. 0.16. What is the difference between the highest and the second highest Gross enrolment ratio (%) in Cambodia?
Provide a succinct answer. 0.94. What is the difference between the highest and the second highest Gross enrolment ratio (%) of Lesotho?
Offer a terse response. 0.56. What is the difference between the highest and the lowest Gross enrolment ratio (%) in High income?
Keep it short and to the point. 19.4. What is the difference between the highest and the lowest Gross enrolment ratio (%) in Burundi?
Provide a short and direct response. 8.46. What is the difference between the highest and the lowest Gross enrolment ratio (%) of Cambodia?
Offer a very short reply. 19.85. What is the difference between the highest and the lowest Gross enrolment ratio (%) in Lesotho?
Ensure brevity in your answer.  28.59. 